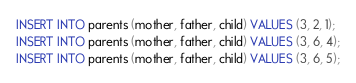<code> <loc_0><loc_0><loc_500><loc_500><_SQL_>INSERT INTO parents (mother, father, child) VALUES (3, 2, 1);
INSERT INTO parents (mother, father, child) VALUES (3, 6, 4);
INSERT INTO parents (mother, father, child) VALUES (3, 6, 5);

</code> 